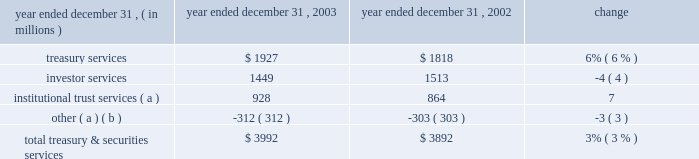J.p .
Morgan chase & co .
/ 2003 annual report 33 corporate credit allocation in 2003 , tss was assigned a corporate credit allocation of pre- tax earnings and the associated capital related to certain credit exposures managed within ib 2019s credit portfolio on behalf of clients shared with tss .
Prior periods have been revised to reflect this allocation .
For 2003 , the impact to tss of this change increased pre-tax operating results by $ 36 million and average allocated capital by $ 712 million , and it decreased sva by $ 65 million .
Pre-tax operating results were $ 46 million lower than in 2002 , reflecting lower loan volumes and higher related expenses , slightly offset by a decrease in credit costs .
Business outlook tss revenue in 2004 is expected to benefit from improved global equity markets and from two recent acquisitions : the november 2003 acquisition of the bank one corporate trust portfolio , and the january 2004 acquisition of citigroup 2019s electronic funds services business .
Tss also expects higher costs as it integrates these acquisitions and continues strategic investments to sup- port business expansion .
By client segment tss dimensions of 2003 revenue diversification by business revenue by geographic region investor services 36% ( 36 % ) other 1% ( 1 % ) institutional trust services 23% ( 23 % ) treasury services 40% ( 40 % ) large corporations 21% ( 21 % ) middle market 18% ( 18 % ) banks 11% ( 11 % ) nonbank financial institutions 44% ( 44 % ) public sector/governments 6% ( 6 % ) europe , middle east & africa 27% ( 27 % ) asia/pacific 9% ( 9 % ) the americas 64% ( 64 % ) ( a ) includes the elimination of revenue related to shared activities with chase middle market in the amount of $ 347 million .
Year ended december 31 , operating revenue .
( a ) includes a portion of the $ 41 million gain on sale of a nonstrategic business in 2003 : $ 1 million in institutional trust services and $ 40 million in other .
( b ) includes the elimination of revenues related to shared activities with chase middle market , and a $ 50 million gain on sale of a non-u.s .
Securities clearing firm in 2002. .
How much was 2003 total treasury & securities services without the benefit of the special gain ( in us$ m ) ? 
Computations: (3992 - 41)
Answer: 3951.0. J.p .
Morgan chase & co .
/ 2003 annual report 33 corporate credit allocation in 2003 , tss was assigned a corporate credit allocation of pre- tax earnings and the associated capital related to certain credit exposures managed within ib 2019s credit portfolio on behalf of clients shared with tss .
Prior periods have been revised to reflect this allocation .
For 2003 , the impact to tss of this change increased pre-tax operating results by $ 36 million and average allocated capital by $ 712 million , and it decreased sva by $ 65 million .
Pre-tax operating results were $ 46 million lower than in 2002 , reflecting lower loan volumes and higher related expenses , slightly offset by a decrease in credit costs .
Business outlook tss revenue in 2004 is expected to benefit from improved global equity markets and from two recent acquisitions : the november 2003 acquisition of the bank one corporate trust portfolio , and the january 2004 acquisition of citigroup 2019s electronic funds services business .
Tss also expects higher costs as it integrates these acquisitions and continues strategic investments to sup- port business expansion .
By client segment tss dimensions of 2003 revenue diversification by business revenue by geographic region investor services 36% ( 36 % ) other 1% ( 1 % ) institutional trust services 23% ( 23 % ) treasury services 40% ( 40 % ) large corporations 21% ( 21 % ) middle market 18% ( 18 % ) banks 11% ( 11 % ) nonbank financial institutions 44% ( 44 % ) public sector/governments 6% ( 6 % ) europe , middle east & africa 27% ( 27 % ) asia/pacific 9% ( 9 % ) the americas 64% ( 64 % ) ( a ) includes the elimination of revenue related to shared activities with chase middle market in the amount of $ 347 million .
Year ended december 31 , operating revenue .
( a ) includes a portion of the $ 41 million gain on sale of a nonstrategic business in 2003 : $ 1 million in institutional trust services and $ 40 million in other .
( b ) includes the elimination of revenues related to shared activities with chase middle market , and a $ 50 million gain on sale of a non-u.s .
Securities clearing firm in 2002. .
In 2003 what was the ratio of the total other income to the gain on sale of a non-u.s securities? 
Computations: (-312 / 50)
Answer: -6.24. 